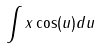<formula> <loc_0><loc_0><loc_500><loc_500>\int x \cos ( u ) d u</formula> 